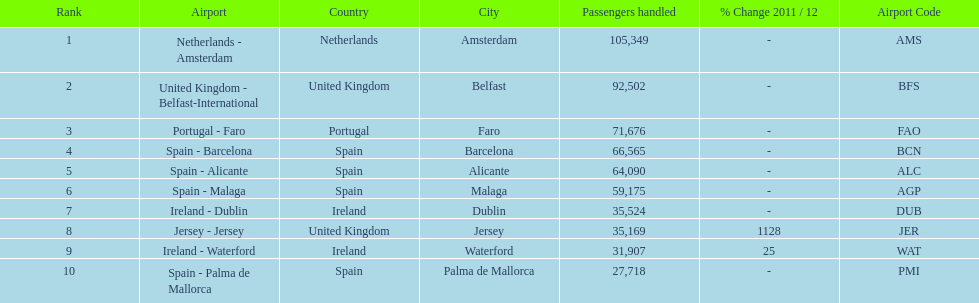Help me parse the entirety of this table. {'header': ['Rank', 'Airport', 'Country', 'City', 'Passengers handled', '% Change 2011 / 12', 'Airport Code'], 'rows': [['1', 'Netherlands - Amsterdam', 'Netherlands', 'Amsterdam', '105,349', '-', 'AMS'], ['2', 'United Kingdom - Belfast-International', 'United Kingdom', 'Belfast', '92,502', '-', 'BFS'], ['3', 'Portugal - Faro', 'Portugal', 'Faro', '71,676', '-', 'FAO'], ['4', 'Spain - Barcelona', 'Spain', 'Barcelona', '66,565', '-', 'BCN'], ['5', 'Spain - Alicante', 'Spain', 'Alicante', '64,090', '-', 'ALC'], ['6', 'Spain - Malaga', 'Spain', 'Malaga', '59,175', '-', 'AGP'], ['7', 'Ireland - Dublin', 'Ireland', 'Dublin', '35,524', '-', 'DUB'], ['8', 'Jersey - Jersey', 'United Kingdom', 'Jersey', '35,169', '1128', 'JER'], ['9', 'Ireland - Waterford', 'Ireland', 'Waterford', '31,907', '25', 'WAT'], ['10', 'Spain - Palma de Mallorca', 'Spain', 'Palma de Mallorca', '27,718', '-', 'PMI']]} Between the topped ranked airport, netherlands - amsterdam, & spain - palma de mallorca, what is the difference in the amount of passengers handled? 77,631. 